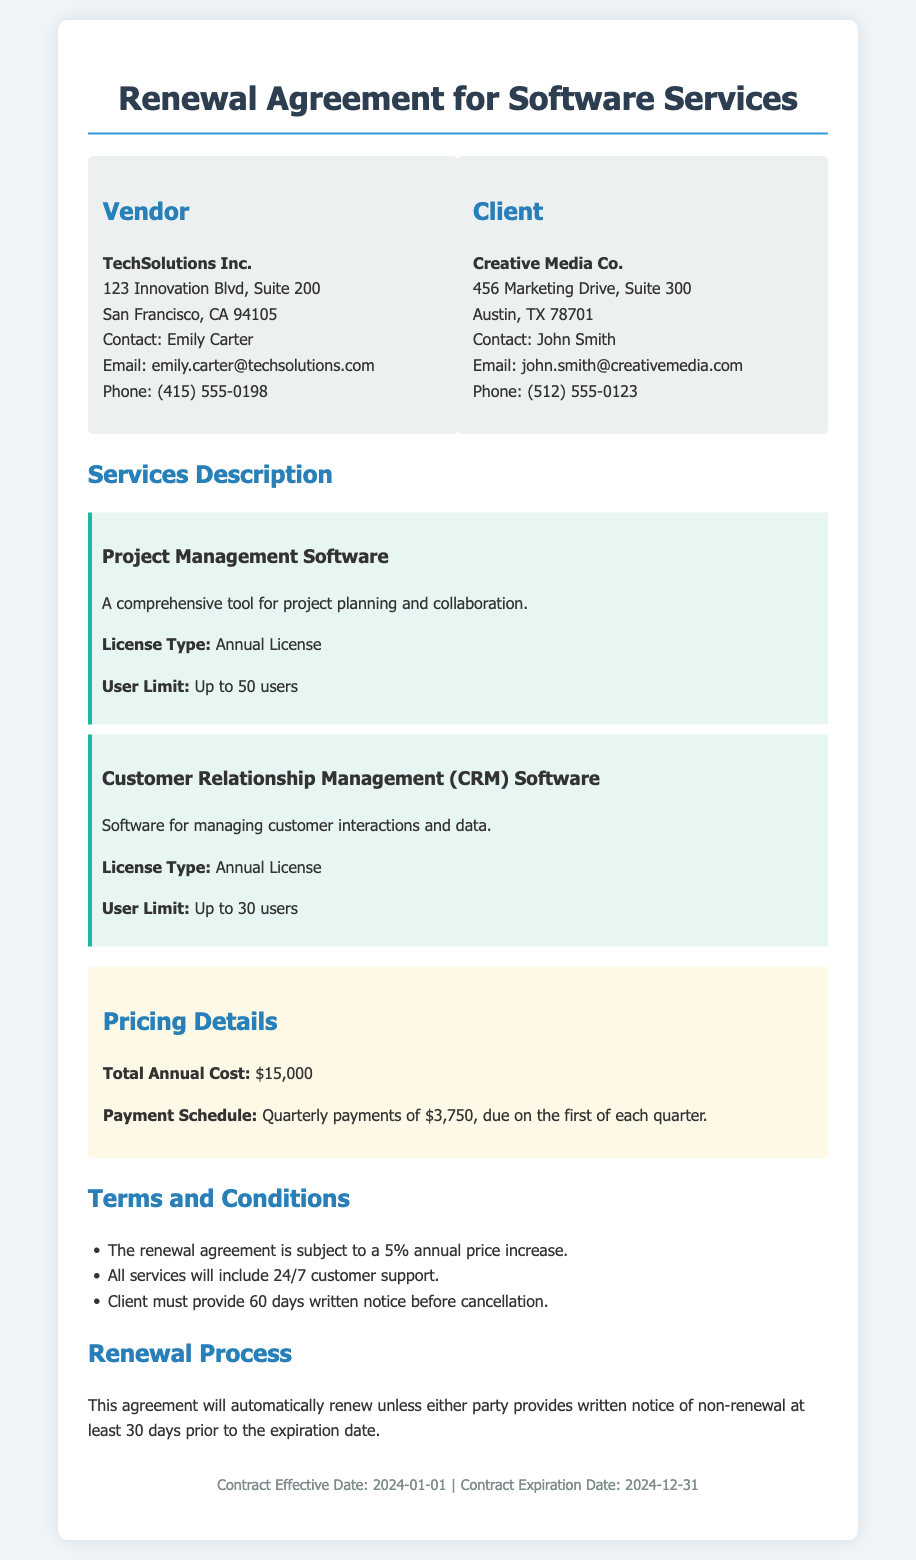What is the vendor's name? The vendor's name is specified in the document as "TechSolutions Inc."
Answer: TechSolutions Inc Who is the client contact? The client contact person is listed in the document as "John Smith."
Answer: John Smith What is the total annual cost? The total annual cost is clearly stated in the pricing section as "$15,000."
Answer: $15,000 What is the user limit for the Project Management Software? The project management software specifies a user limit of "Up to 50 users."
Answer: Up to 50 users What is the payment schedule? The payment schedule is outlined as "Quarterly payments of $3,750, due on the first of each quarter."
Answer: Quarterly payments of $3,750 What is the annual price increase percentage? The document specifies an annual price increase of "5%."
Answer: 5% How long before cancellation must the client provide notice? The client must provide "60 days written notice" before cancellation.
Answer: 60 days What happens if neither party provides notice of non-renewal? The agreement will "automatically renew" unless notice is given.
Answer: Automatically renew When does the contract expire? The document lists the contract expiration date as "2024-12-31."
Answer: 2024-12-31 